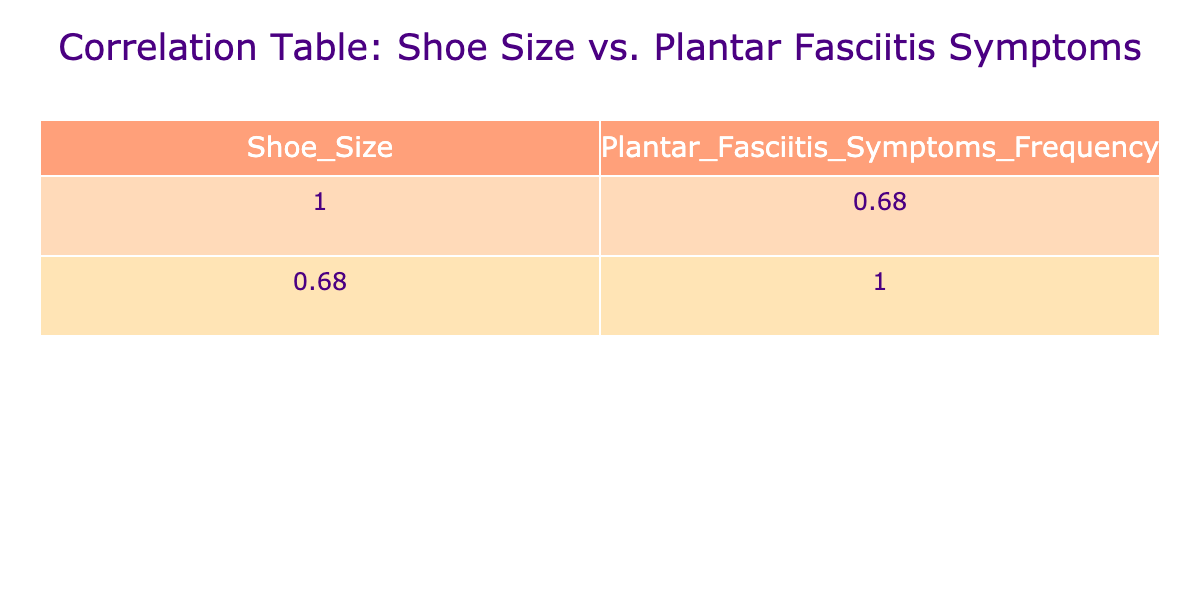What is the frequency of plantar fasciitis symptoms for shoe size 8? The table lists the frequency of plantar fasciitis symptoms corresponding to each shoe size. For shoe size 8, the frequency is directly given in the table as 4.
Answer: 4 What shoesize has the highest frequency of plantar fasciitis symptoms? By checking the frequencies in the table, the highest frequency of plantar fasciitis symptoms listed is 10, which corresponds to shoe size 12.
Answer: 12 What is the average frequency of plantar fasciitis symptoms for shoe sizes 5 to 9? To find the average frequency, I need to first gather the frequencies for shoe sizes 5 to 9, which are 3, 4, 2, 5, 3, 6, 4, and 7. Adding these gives a total of 34 and dividing by the number of shoe sizes (8) results in an average of 4.25.
Answer: 4.25 Does shoe size 10 have a higher frequency of symptoms than shoe size 6? Comparing the frequencies in the table, shoe size 10 has a frequency of 6, while shoe size 6 has a frequency of 2. Since 6 is greater than 2, the answer is yes.
Answer: Yes What is the difference in frequency of plantar fasciitis symptoms between shoe sizes 9 and 11? From the table, the frequency for shoe size 9 is 7, and for shoe size 11, it is 5. The difference is calculated as 7 - 5 = 2.
Answer: 2 Which shoe sizes have a frequency of symptoms that is equal or greater than 8? According to the table, shoe sizes with frequencies of 8 or more are 8.5 (8), 9.5 (9), and 12 (10). These are the sizes with the specified frequencies.
Answer: 8.5, 9.5, 12 What is the median frequency of plantar fasciitis symptoms across all shoe sizes? To find the median, I must list all frequencies in ascending order: 2, 3, 3, 4, 4, 5, 5, 6, 6, 7, 8, 9, 10. As there are 13 data points, the median is the 7th number in this ordered list, which is 5.
Answer: 5 Is there a negative correlation observed between shoe size and frequency of plantar fasciitis symptoms? A correlation indicates how two variables relate; seeing that as shoe size increases, frequency also tends to increase (e.g., size 12 has more symptoms than size 5), thus there's no negative correlation present.
Answer: No 